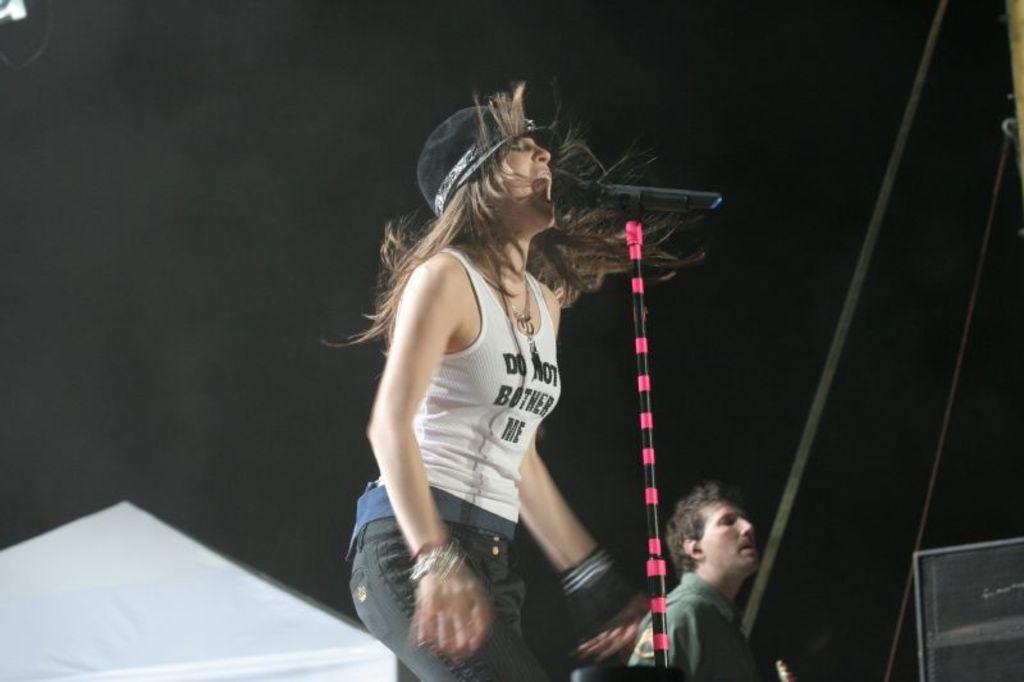Could you give a brief overview of what you see in this image? In this picture there is a girl in the center of the image, she is singing and there is mic in front of her and there is a man in the background area of the image and there is a speaker in the bottom side of the image and the background area of the image is black. 